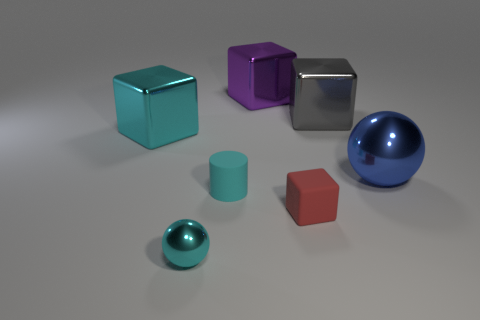Are there any gray blocks that are behind the metal sphere to the left of the shiny sphere that is on the right side of the small ball?
Make the answer very short. Yes. What is the shape of the object that is the same material as the tiny cylinder?
Your answer should be compact. Cube. Is there any other thing that is the same shape as the cyan matte thing?
Your response must be concise. No. The blue object has what shape?
Your response must be concise. Sphere. There is a big shiny thing left of the tiny ball; is its shape the same as the purple thing?
Make the answer very short. Yes. Is the number of large metal cubes left of the tiny red cube greater than the number of cyan metal things in front of the tiny rubber cylinder?
Give a very brief answer. Yes. How many other objects are the same size as the gray cube?
Offer a terse response. 3. Is the shape of the blue object the same as the cyan metal object that is on the right side of the cyan metallic cube?
Offer a very short reply. Yes. How many metal objects are yellow cubes or large purple cubes?
Offer a very short reply. 1. Are there any matte blocks of the same color as the small shiny object?
Offer a terse response. No. 